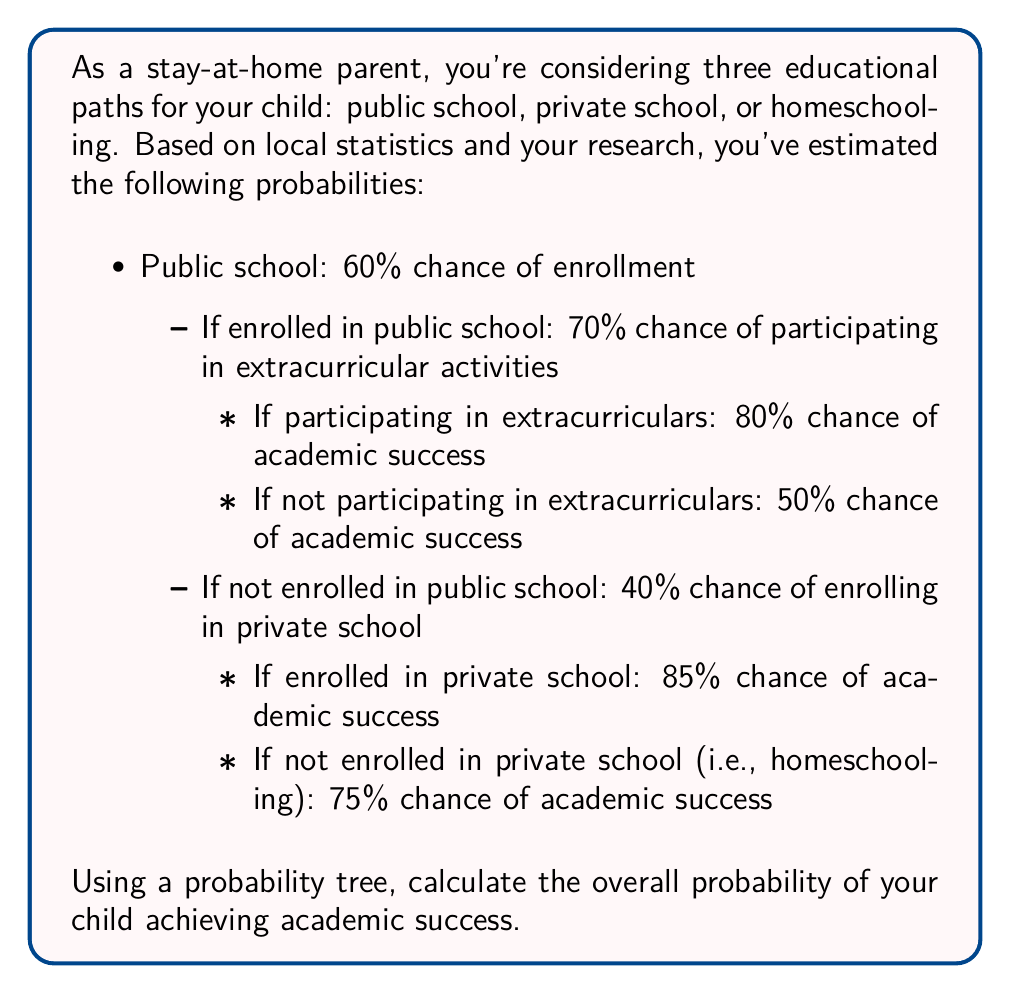Could you help me with this problem? To solve this problem, we'll construct a probability tree and calculate the probability of academic success for each path. Then, we'll sum these probabilities to find the overall probability of academic success.

Let's break it down step by step:

1. Public school path:
   a. Probability of enrolling in public school: 0.60
   b. Probability of participating in extracurriculars: 0.70
   c. Probability of success with extracurriculars: 0.80
   d. Probability of success without extracurriculars: 0.50

   Probability of success through public school with extracurriculars:
   $$ P(\text{Public} \cap \text{Extracurricular} \cap \text{Success}) = 0.60 \times 0.70 \times 0.80 = 0.336 $$

   Probability of success through public school without extracurriculars:
   $$ P(\text{Public} \cap \text{No Extracurricular} \cap \text{Success}) = 0.60 \times 0.30 \times 0.50 = 0.090 $$

2. Private school path:
   a. Probability of not enrolling in public school: 0.40
   b. Probability of enrolling in private school: 0.40
   c. Probability of success in private school: 0.85

   Probability of success through private school:
   $$ P(\text{Not Public} \cap \text{Private} \cap \text{Success}) = 0.40 \times 0.40 \times 0.85 = 0.136 $$

3. Homeschooling path:
   a. Probability of not enrolling in public school: 0.40
   b. Probability of not enrolling in private school: 0.60
   c. Probability of success in homeschooling: 0.75

   Probability of success through homeschooling:
   $$ P(\text{Not Public} \cap \text{Not Private} \cap \text{Success}) = 0.40 \times 0.60 \times 0.75 = 0.180 $$

Now, we sum all these probabilities to get the overall probability of academic success:

$$ P(\text{Success}) = 0.336 + 0.090 + 0.136 + 0.180 = 0.742 $$

Therefore, the overall probability of your child achieving academic success is 0.742 or 74.2%.
Answer: The overall probability of your child achieving academic success is 0.742 or 74.2%. 